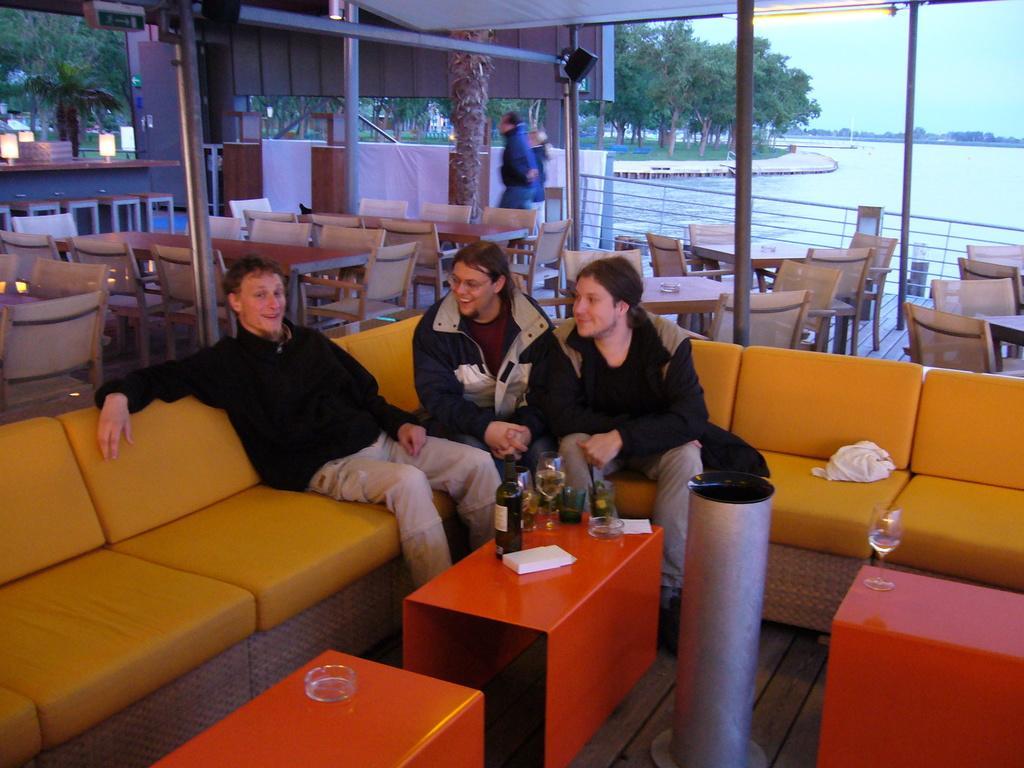How would you summarize this image in a sentence or two? In this image I see 3 men sitting on the couch and there is a table in front and there is a bottle and few glasses on it and I can also see that there are 2 more tables over here and there glasses on it. In the background i can see lot of chairs and tables and a man over here and I can also see lot of trees, water and the sky. 